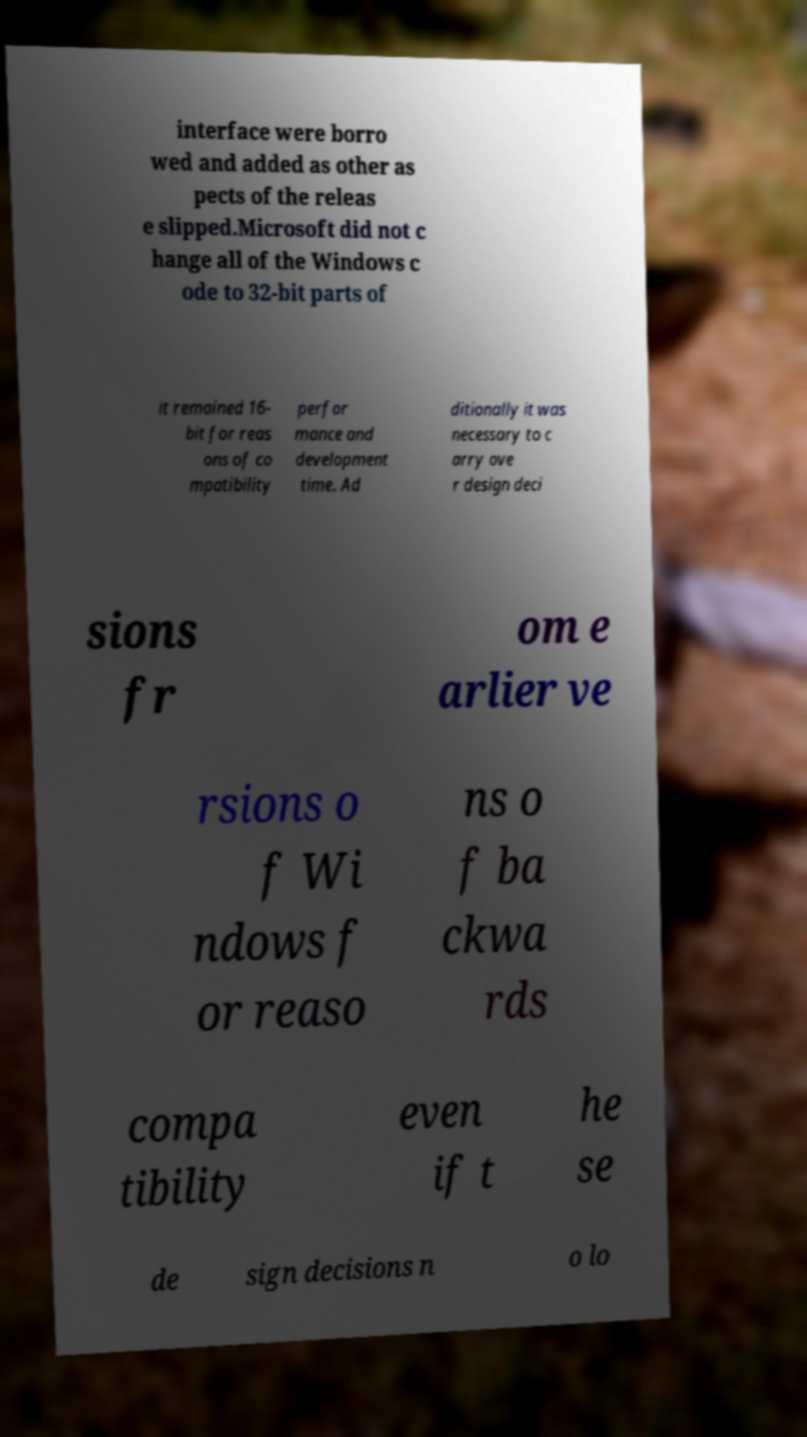Please read and relay the text visible in this image. What does it say? interface were borro wed and added as other as pects of the releas e slipped.Microsoft did not c hange all of the Windows c ode to 32-bit parts of it remained 16- bit for reas ons of co mpatibility perfor mance and development time. Ad ditionally it was necessary to c arry ove r design deci sions fr om e arlier ve rsions o f Wi ndows f or reaso ns o f ba ckwa rds compa tibility even if t he se de sign decisions n o lo 